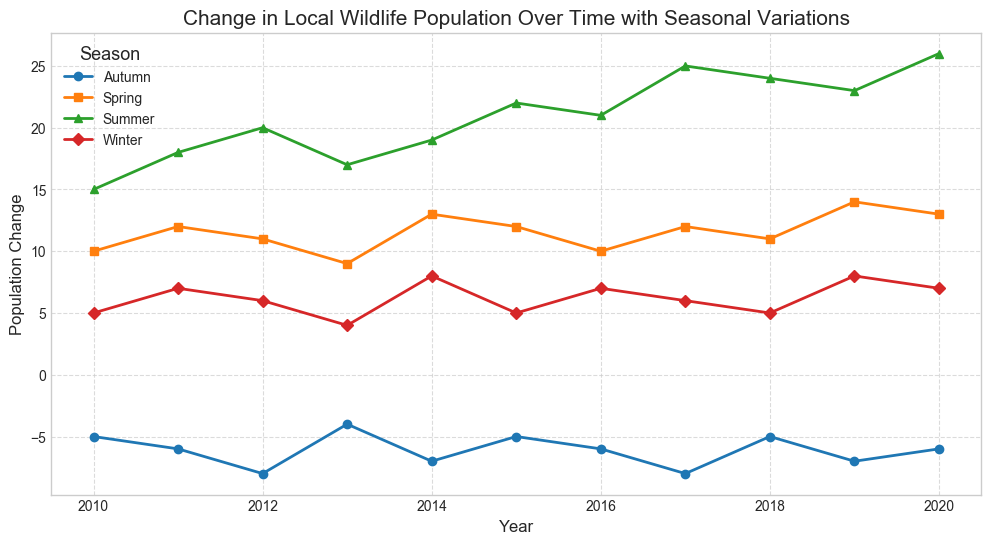When is the population change highest during the summer? To determine when the population change is highest during the summer, look at the summer values across all years on the chart. The year 2020 has the highest value of 26.
Answer: 2020 Which season consistently shows the lowest population change over time? By examining the graph, you can see that the autumn season always has negative values, making it the season with the lowest population change consistently.
Answer: Autumn How does the winter population change in 2018 compare to 2019? Check the winter values for 2018 and 2019 on the graph. The value is 5 in 2018 and 8 in 2019. Thus, there is an increase of 3 in 2019 compared to 2018.
Answer: It increases by 3 What is the average population change during the spring season from 2010 to 2015? Identify the spring values between 2010 and 2015: 10, 12, 11, 9, 13, 12. Add these up to get 67, then divide by the number of years (6). Average = 67 / 6 ≈ 11.17.
Answer: 11.17 Compare the summer population change in 2015 and 2020. Which year has a higher change, and by how much? For summer, the value in 2015 is 22, and in 2020 it is 26. 26 - 22 = 4. Thus, 2020 has a higher change by 4.
Answer: 2020 by 4 Identify the year with the smallest negative population change during autumn. Look for the smallest (least negative) value in autumn across all years. The smallest negative value is -4 in 2013.
Answer: 2013 What is the overall trend in summer population change from 2010 to 2020? To observe the trend, check the summer values from 2010 to 2020. The values show a general increase from 15 to 26 over these years.
Answer: Increasing What is the difference between the highest and lowest population changes in any single season? Identify the highest and lowest values overall: highest is 26 (Summer 2020) and lowest is -8 (Autumn 2012, 2017). Difference = 26 - (-8) = 34.
Answer: 34 Calculate the total population change in winter for the decade 2011-2020. Sum the winter values from 2011 to 2020: 7, 6, 4, 8, 5, 7, 6, 5, 8, 7. Total is 63.
Answer: 63 